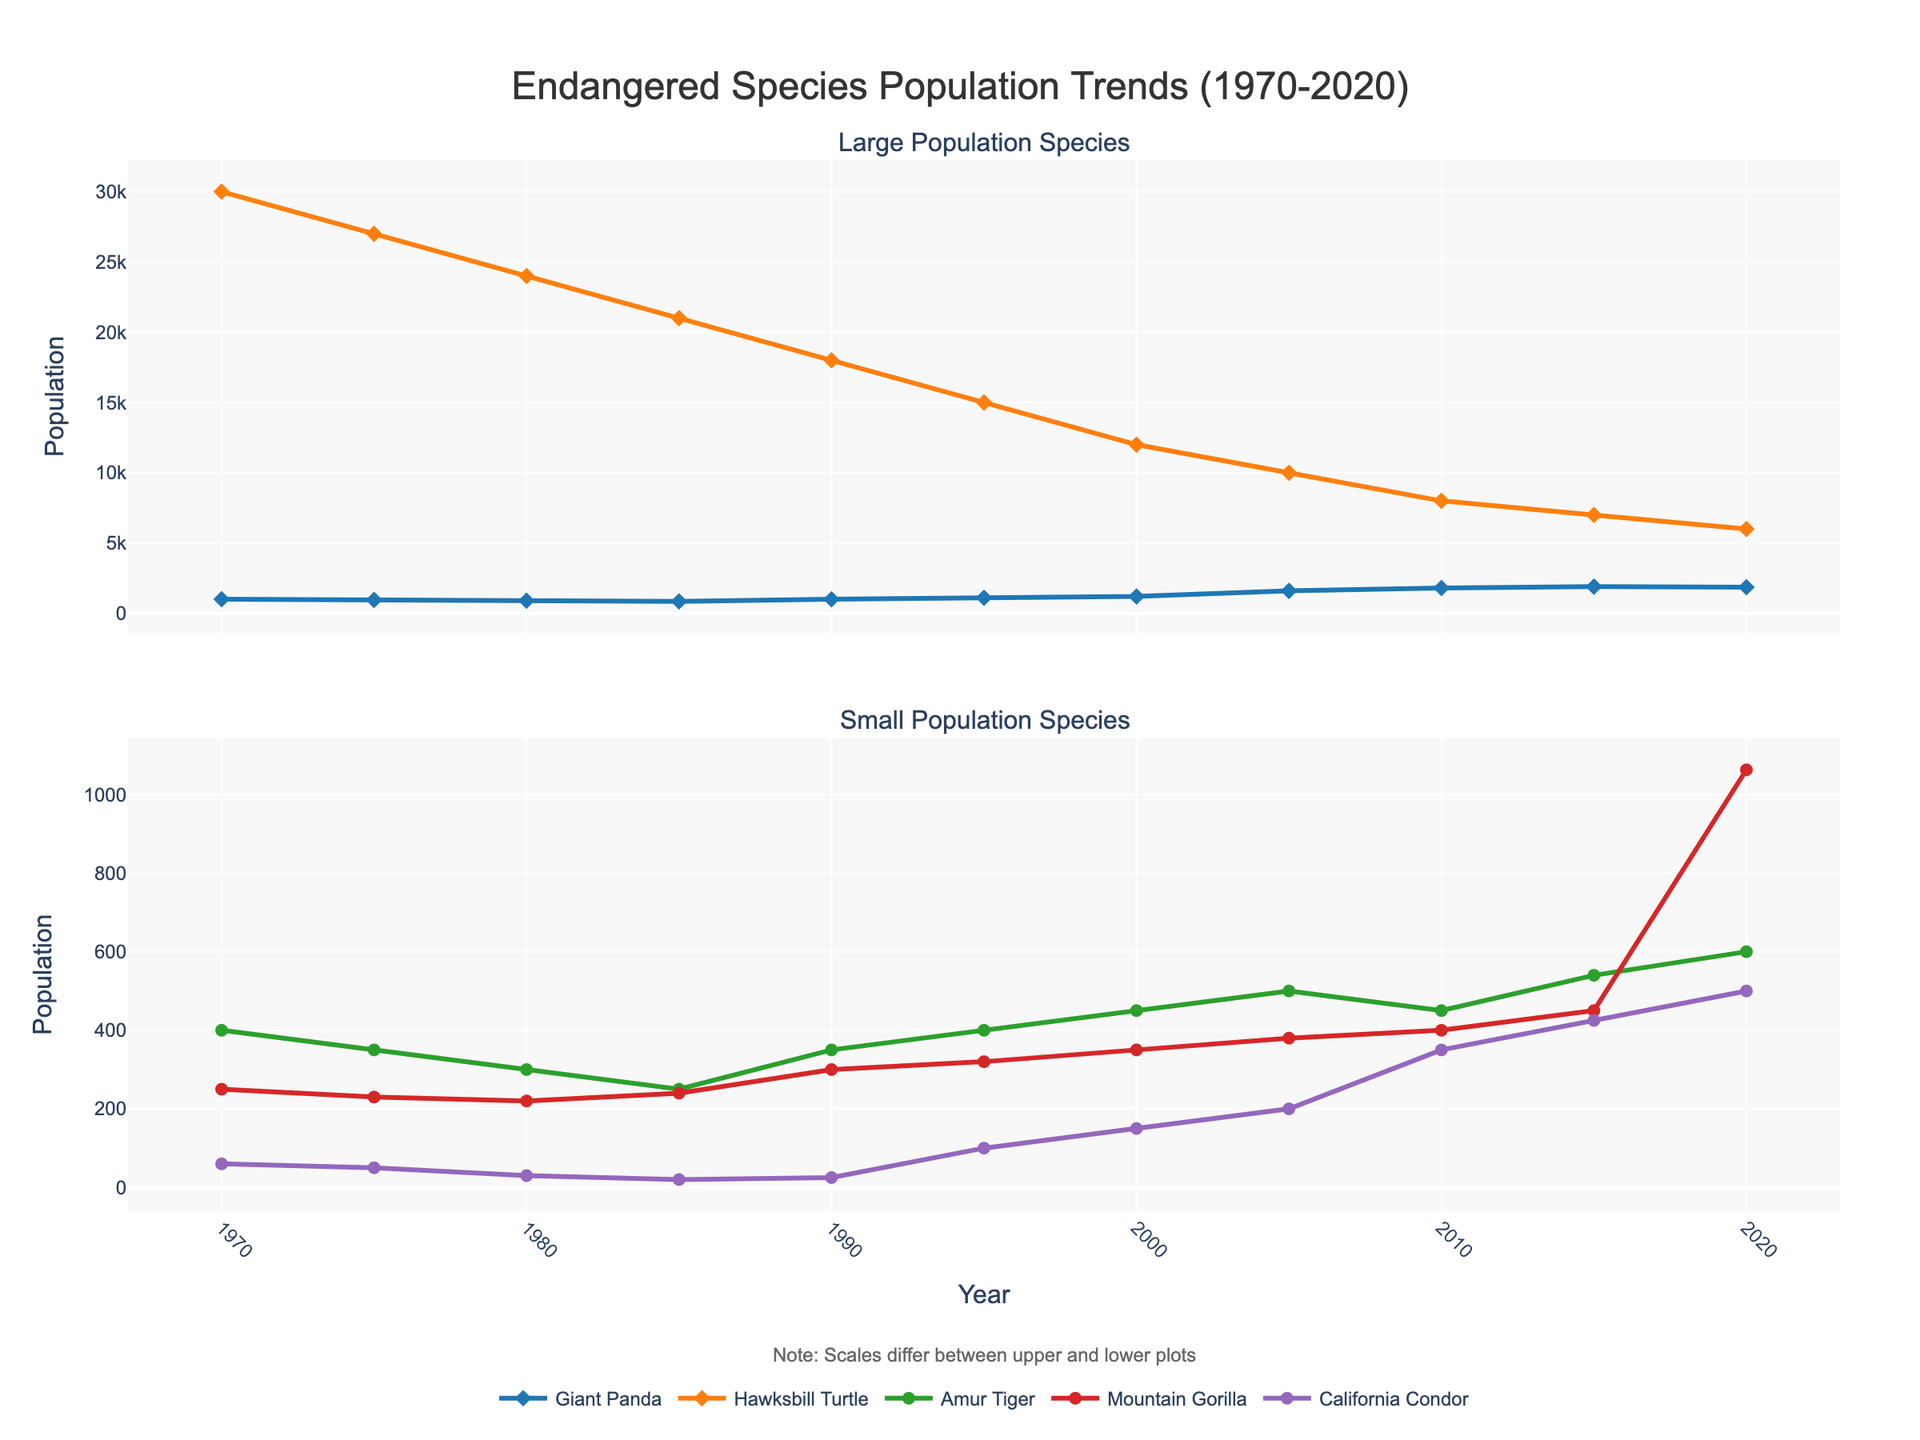Which species had the highest population in 1970? The data shows that Hawksbill Turtle had the highest population in 1970 with a count of 30,000. The other species had significantly lower populations.
Answer: Hawksbill Turtle How did the population trend of Mountain Gorillas change between 2015 and 2020? Between 2015 and 2020, the population of Mountain Gorillas increased from 450 to 1063. This indicates a significant upward trend.
Answer: Increased significantly Which species had a sharper increase in population between 2000 and 2005: California Condor or Amur Tiger? California Condor's population increased from 150 to 200, which is a rise of 50. Amur Tiger's population increased from 450 to 500, an increase of 50 as well. However, relative to their starting populations, California Condor had a sharper increase since 50/150 is greater than 50/450.
Answer: California Condor What is the difference in population size of the Giant Panda between 1980 and 2020? The population of the Giant Panda in 1980 was 900, while in 2020 it was 1864. The difference is 1864 - 900 = 964.
Answer: 964 Which species' population consistently decreased between 1970 and 2020? The Hawksbill Turtle's population shows a consistent decrease between 1970 (30,000) and 2020 (6,000). None of the other species had such a consistent decrease.
Answer: Hawksbill Turtle In which decade did the Mountain Gorilla's population experience the most dramatic growth? Between 2010 and 2015, the population grew from 400 to 450, and then between 2015 and 2020, it surged to 1063. The period between 2015 and 2020 shows the most dramatic growth.
Answer: 2015-2020 What is the average population of the Amur Tiger from 1970 to 2020? The populations across the years are 400, 350, 300, 250, 350, 400, 450, 500, 450, 540, 600. The sum is 4,590, and there are 11 data points, so the average is 4,590 / 11 ≈ 417.27.
Answer: 417.27 Compare the population trends of the Giant Panda and California Condor from 1990 to 2020. Which had a greater overall increase in numbers? The Giant Panda's population in 1990 was 1000 and in 2020 was 1864, an increase of 864. The California Condor's population in 1990 was 25 and in 2020 was 500, an increase of 475. Therefore, the Giant Panda had a greater overall increase in numbers.
Answer: Giant Panda How many species had a population growth in 1995 compared to 1990? Comparing the populations between 1990 and 1995: Giant Panda (1000 to 1100), Amur Tiger (350 to 400), Mountain Gorilla (300 to 320), Hawksbill Turtle (18000 to 15000), California Condor (25 to 100). Four species had a growth: Giant Panda, Amur Tiger, Mountain Gorilla, and California Condor.
Answer: Four species By how much did the population of the Hawksbill Turtle decrease from 1970 to 2020? The population of the Hawksbill Turtle in 1970 was 30,000 and in 2020 it was 6,000. The decrease is 30,000 - 6,000 = 24,000.
Answer: 24,000 